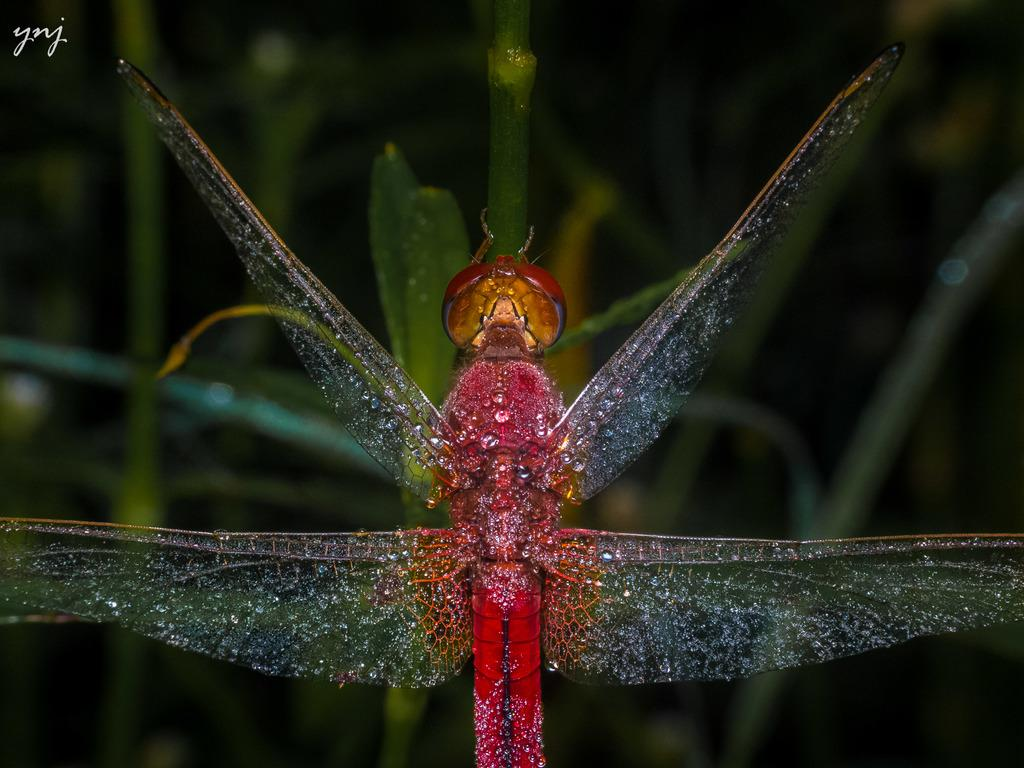What is the main subject of the image? There is an insect in the image. Where is the insect located? The insect is sitting on a leaf. Can you describe the background of the image? The background of the image is blurry. How many clocks can be seen in the image? There are no clocks present in the image. What type of badge is the insect wearing in the image? There is no badge present on the insect in the image. 